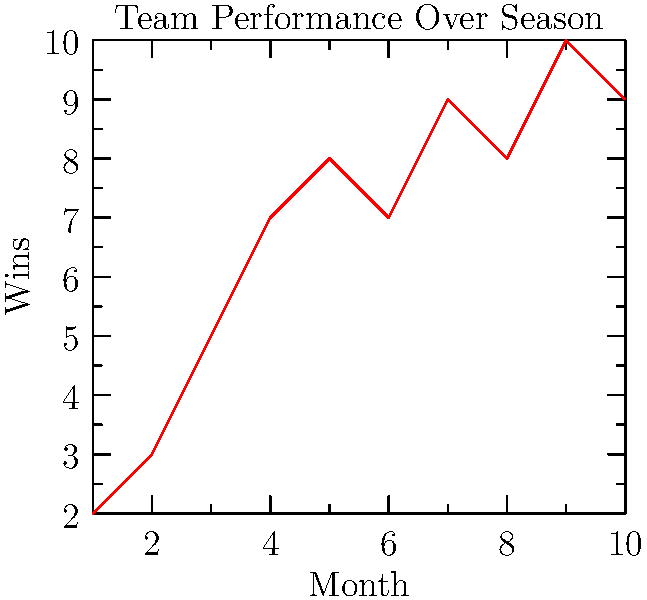Based on the line graph showing the team's performance over a season, what is the total number of wins accumulated by the end of the 10th month? To determine the total number of wins accumulated by the end of the 10th month, we need to follow these steps:

1. Identify the number of wins for each month:
   Month 1: 2 wins
   Month 2: 3 wins
   Month 3: 5 wins
   Month 4: 7 wins
   Month 5: 8 wins
   Month 6: 7 wins
   Month 7: 9 wins
   Month 8: 8 wins
   Month 9: 10 wins
   Month 10: 9 wins

2. Sum up all the wins:
   $2 + 3 + 5 + 7 + 8 + 7 + 9 + 8 + 10 + 9 = 68$

Therefore, the total number of wins accumulated by the end of the 10th month is 68.
Answer: 68 wins 